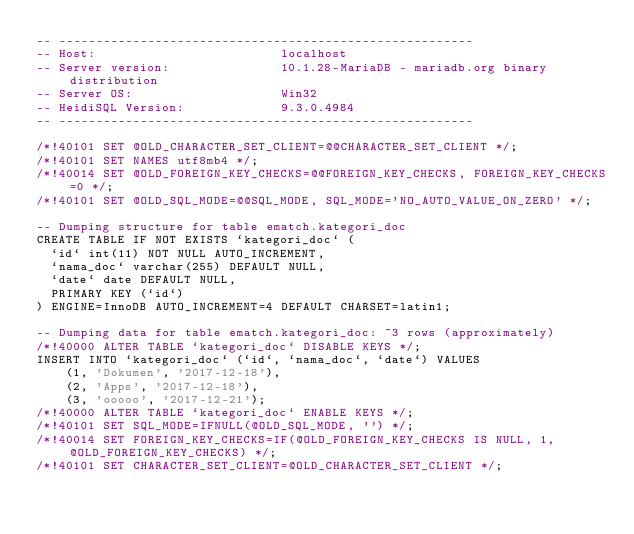Convert code to text. <code><loc_0><loc_0><loc_500><loc_500><_SQL_>-- --------------------------------------------------------
-- Host:                         localhost
-- Server version:               10.1.28-MariaDB - mariadb.org binary distribution
-- Server OS:                    Win32
-- HeidiSQL Version:             9.3.0.4984
-- --------------------------------------------------------

/*!40101 SET @OLD_CHARACTER_SET_CLIENT=@@CHARACTER_SET_CLIENT */;
/*!40101 SET NAMES utf8mb4 */;
/*!40014 SET @OLD_FOREIGN_KEY_CHECKS=@@FOREIGN_KEY_CHECKS, FOREIGN_KEY_CHECKS=0 */;
/*!40101 SET @OLD_SQL_MODE=@@SQL_MODE, SQL_MODE='NO_AUTO_VALUE_ON_ZERO' */;

-- Dumping structure for table ematch.kategori_doc
CREATE TABLE IF NOT EXISTS `kategori_doc` (
  `id` int(11) NOT NULL AUTO_INCREMENT,
  `nama_doc` varchar(255) DEFAULT NULL,
  `date` date DEFAULT NULL,
  PRIMARY KEY (`id`)
) ENGINE=InnoDB AUTO_INCREMENT=4 DEFAULT CHARSET=latin1;

-- Dumping data for table ematch.kategori_doc: ~3 rows (approximately)
/*!40000 ALTER TABLE `kategori_doc` DISABLE KEYS */;
INSERT INTO `kategori_doc` (`id`, `nama_doc`, `date`) VALUES
	(1, 'Dokumen', '2017-12-18'),
	(2, 'Apps', '2017-12-18'),
	(3, 'ooooo', '2017-12-21');
/*!40000 ALTER TABLE `kategori_doc` ENABLE KEYS */;
/*!40101 SET SQL_MODE=IFNULL(@OLD_SQL_MODE, '') */;
/*!40014 SET FOREIGN_KEY_CHECKS=IF(@OLD_FOREIGN_KEY_CHECKS IS NULL, 1, @OLD_FOREIGN_KEY_CHECKS) */;
/*!40101 SET CHARACTER_SET_CLIENT=@OLD_CHARACTER_SET_CLIENT */;
</code> 